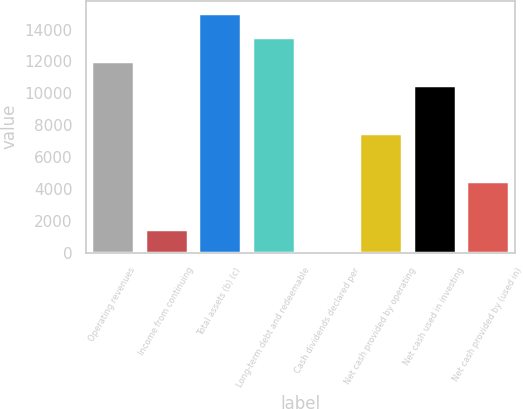<chart> <loc_0><loc_0><loc_500><loc_500><bar_chart><fcel>Operating revenues<fcel>Income from continuing<fcel>Total assets (b) (c)<fcel>Long-term debt and redeemable<fcel>Cash dividends declared per<fcel>Net cash provided by operating<fcel>Net cash used in investing<fcel>Net cash provided by (used in)<nl><fcel>12051.4<fcel>1507.41<fcel>15064<fcel>13557.7<fcel>1.12<fcel>7532.57<fcel>10545.1<fcel>4519.99<nl></chart> 